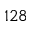<formula> <loc_0><loc_0><loc_500><loc_500>1 2 8</formula> 